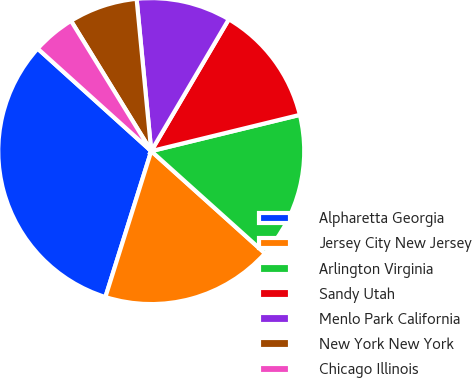Convert chart. <chart><loc_0><loc_0><loc_500><loc_500><pie_chart><fcel>Alpharetta Georgia<fcel>Jersey City New Jersey<fcel>Arlington Virginia<fcel>Sandy Utah<fcel>Menlo Park California<fcel>New York New York<fcel>Chicago Illinois<nl><fcel>31.84%<fcel>18.19%<fcel>15.46%<fcel>12.73%<fcel>9.99%<fcel>7.26%<fcel>4.53%<nl></chart> 